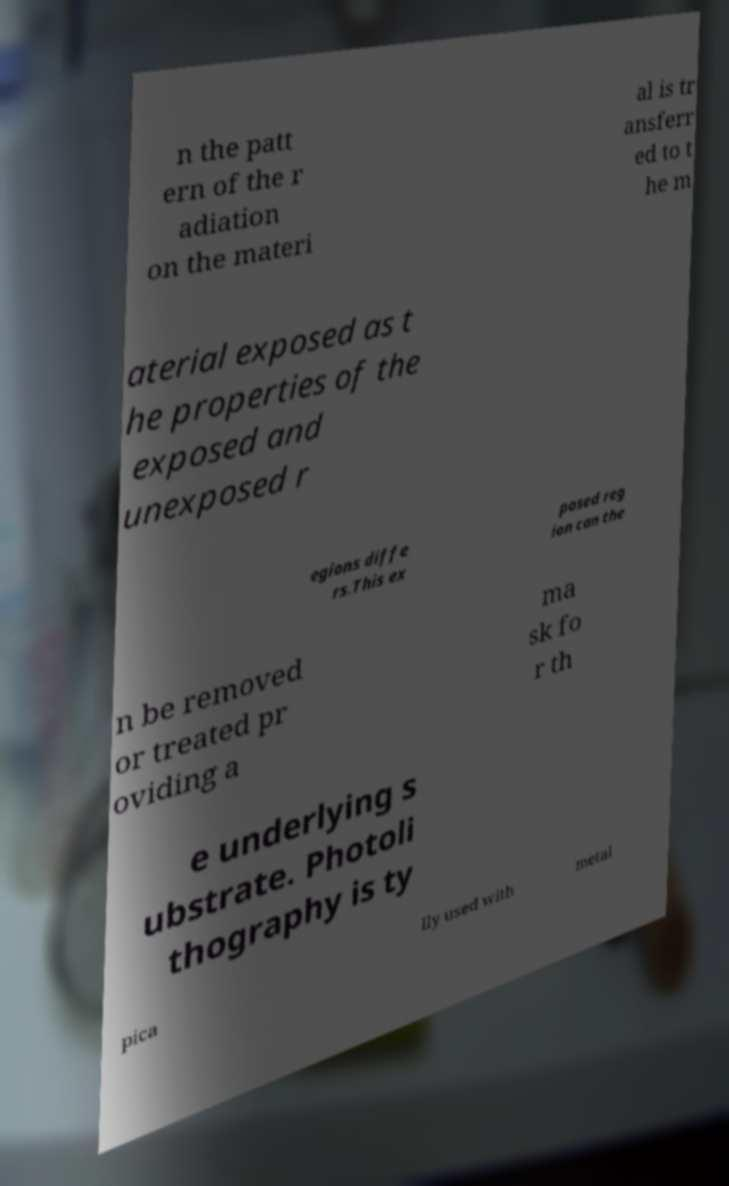I need the written content from this picture converted into text. Can you do that? n the patt ern of the r adiation on the materi al is tr ansferr ed to t he m aterial exposed as t he properties of the exposed and unexposed r egions diffe rs.This ex posed reg ion can the n be removed or treated pr oviding a ma sk fo r th e underlying s ubstrate. Photoli thography is ty pica lly used with metal 